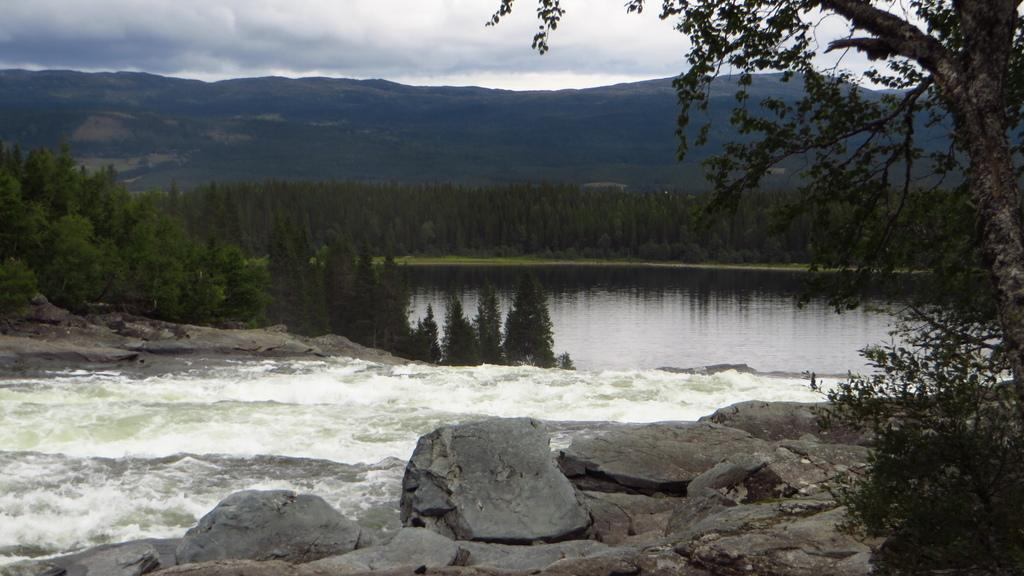What type of natural features can be seen in the image? There are rocks, trees, and mountains visible in the image. What else can be seen in the image besides natural features? There is water visible in the image. What is visible in the background of the image? The sky is visible in the background of the image. What can be observed in the sky? There are clouds in the sky. Where is the church located in the image? There is no church present in the image. Can you see any deer in the image? There are no deer visible in the image. 